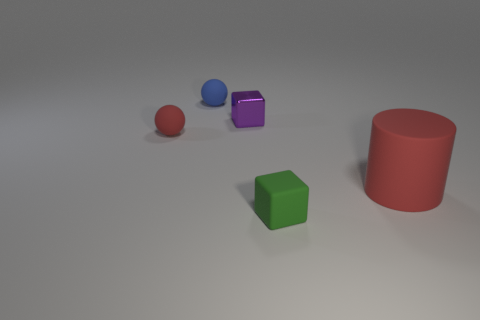Is there any other thing that is the same material as the tiny purple block?
Your response must be concise. No. Do the big cylinder and the blue object have the same material?
Your answer should be compact. Yes. What is the color of the other matte block that is the same size as the purple block?
Provide a short and direct response. Green. What number of other objects are the same shape as the small blue matte thing?
Your response must be concise. 1. Is the size of the shiny cube the same as the sphere that is in front of the blue rubber object?
Make the answer very short. Yes. What number of objects are tiny purple shiny objects or large yellow cylinders?
Give a very brief answer. 1. How many other objects are the same size as the red cylinder?
Provide a succinct answer. 0. Does the big matte cylinder have the same color as the ball that is in front of the small metallic thing?
Make the answer very short. Yes. How many spheres are either small green objects or tiny blue things?
Keep it short and to the point. 1. Are there any other things of the same color as the shiny object?
Offer a very short reply. No. 